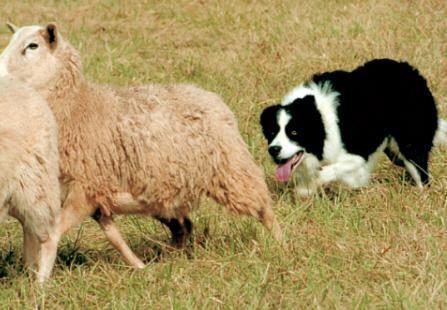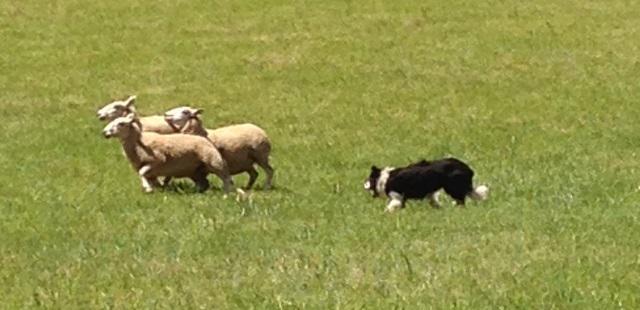The first image is the image on the left, the second image is the image on the right. Given the left and right images, does the statement "The dog in the image on the left is moving toward the camera." hold true? Answer yes or no. No. The first image is the image on the left, the second image is the image on the right. Examine the images to the left and right. Is the description "One image focuses on the dog close to one sheep." accurate? Answer yes or no. Yes. 